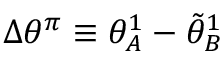Convert formula to latex. <formula><loc_0><loc_0><loc_500><loc_500>\Delta \theta ^ { \pi } \equiv \theta _ { A } ^ { 1 } - \tilde { \theta } _ { B } ^ { 1 }</formula> 